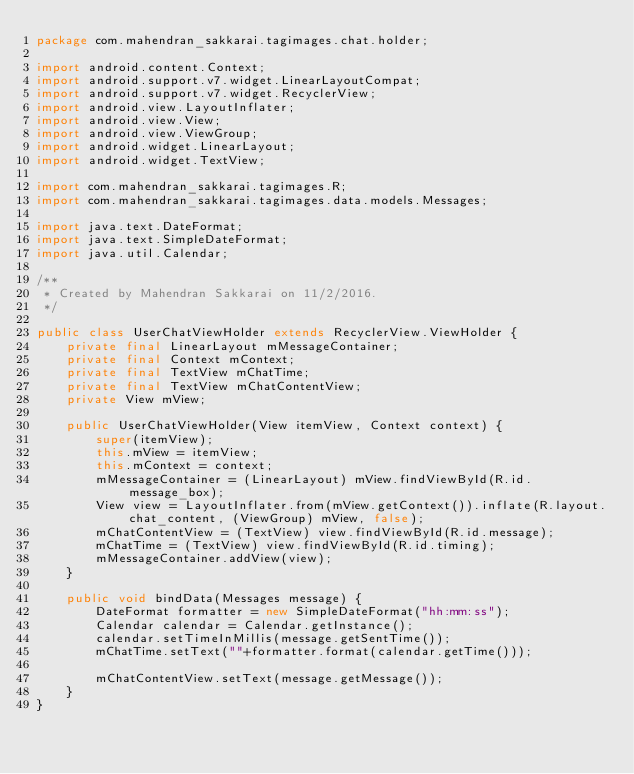Convert code to text. <code><loc_0><loc_0><loc_500><loc_500><_Java_>package com.mahendran_sakkarai.tagimages.chat.holder;

import android.content.Context;
import android.support.v7.widget.LinearLayoutCompat;
import android.support.v7.widget.RecyclerView;
import android.view.LayoutInflater;
import android.view.View;
import android.view.ViewGroup;
import android.widget.LinearLayout;
import android.widget.TextView;

import com.mahendran_sakkarai.tagimages.R;
import com.mahendran_sakkarai.tagimages.data.models.Messages;

import java.text.DateFormat;
import java.text.SimpleDateFormat;
import java.util.Calendar;

/**
 * Created by Mahendran Sakkarai on 11/2/2016.
 */

public class UserChatViewHolder extends RecyclerView.ViewHolder {
    private final LinearLayout mMessageContainer;
    private final Context mContext;
    private final TextView mChatTime;
    private final TextView mChatContentView;
    private View mView;

    public UserChatViewHolder(View itemView, Context context) {
        super(itemView);
        this.mView = itemView;
        this.mContext = context;
        mMessageContainer = (LinearLayout) mView.findViewById(R.id.message_box);
        View view = LayoutInflater.from(mView.getContext()).inflate(R.layout.chat_content, (ViewGroup) mView, false);
        mChatContentView = (TextView) view.findViewById(R.id.message);
        mChatTime = (TextView) view.findViewById(R.id.timing);
        mMessageContainer.addView(view);
    }

    public void bindData(Messages message) {
        DateFormat formatter = new SimpleDateFormat("hh:mm:ss");
        Calendar calendar = Calendar.getInstance();
        calendar.setTimeInMillis(message.getSentTime());
        mChatTime.setText(""+formatter.format(calendar.getTime()));

        mChatContentView.setText(message.getMessage());
    }
}
</code> 